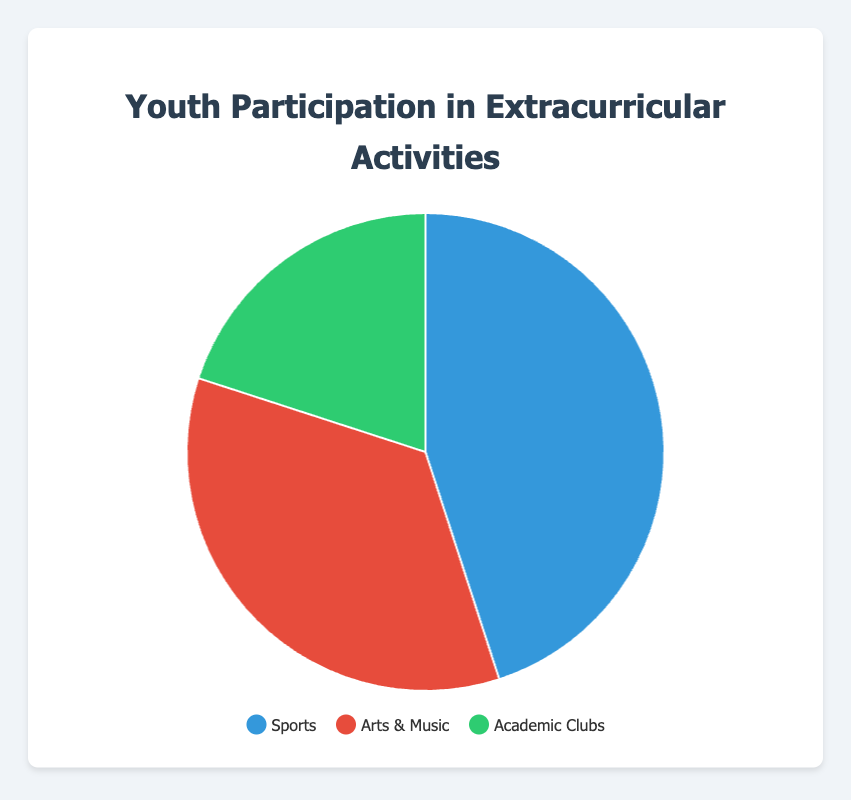Which category has the highest participation rate? The pie chart shows three categories with their respective participation rates: Sports (45%), Arts & Music (35%), and Academic Clubs (20%). The highest percentage is 45%, which belongs to Sports.
Answer: Sports What is the difference in participation rate between Sports and Academic Clubs? The participation rate for Sports is 45% and for Academic Clubs is 20%. Subtracting 20 from 45 gives us the difference: 45% - 20% = 25%.
Answer: 25% Which category represents the smallest portion of the pie chart? The pie chart displays participation rates for three categories: Sports (45%), Arts & Music (35%), and Academic Clubs (20%). The smallest percentage is 20%, which corresponds to Academic Clubs.
Answer: Academic Clubs What is the combined participation rate of Sports and Arts & Music? The pie chart provides the individual participation rates for Sports (45%) and Arts & Music (35%). Adding these two percentages gives us the combined rate: 45% + 35% = 80%.
Answer: 80% What percentage of the pie chart is dedicated to activities other than Sports? The participation rate for Sports is 45%. Therefore, the remaining portion dedicated to other activities (Arts & Music and Academic Clubs) is calculated by subtracting 45 from 100: 100% - 45% = 55%.
Answer: 55% Which category's participation aligns with fostering creativity and emotional expression? The pie chart shows the categories and their participation rates. Arts & Music is noted to foster creativity and emotional expression, and it has a 35% participation rate.
Answer: Arts & Music What is the average participation rate across all categories? The pie chart presents the following participation rates: Sports (45%), Arts & Music (35%), and Academic Clubs (20%). To find the average, add the percentages and divide by the number of categories: (45% + 35% + 20%) / 3 = 100% / 3 ≈ 33.33%.
Answer: 33.33% How does the participation rate of Arts & Music compare to the combined rate of Sports and Academic Clubs? The participation rate for Arts & Music is 35%. The combined rate for Sports (45%) and Academic Clubs (20%) is 65%. Arts & Music's rate is less than the combined rate of Sports and Academic Clubs.
Answer: Less than What color represents the category with the second highest participation rate? The second highest participation rate in the pie chart is Arts & Music at 35%. In the legend, Arts & Music is associated with the red color.
Answer: Red If the total number of participants is 200, how many participants are involved in Academic Clubs? The participation rate for Academic Clubs is 20%. To find the number of participants, multiply the total by the rate: 200 * 0.20 = 40.
Answer: 40 